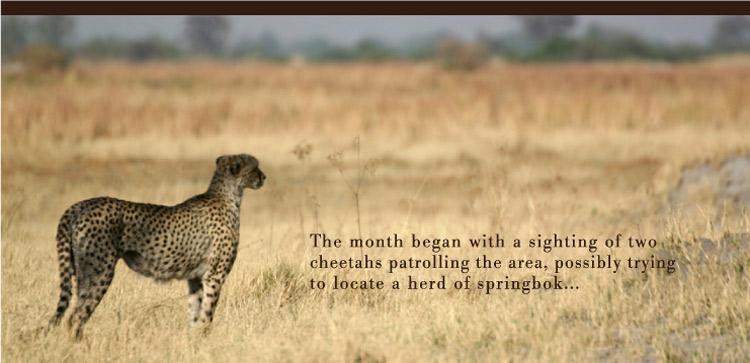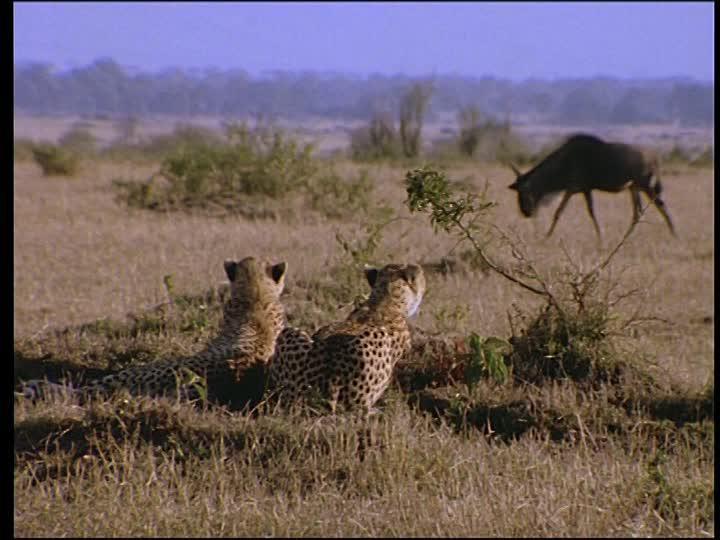The first image is the image on the left, the second image is the image on the right. Assess this claim about the two images: "Prey animals are visible in the background of the left image.". Correct or not? Answer yes or no. No. The first image is the image on the left, the second image is the image on the right. Given the left and right images, does the statement "Two cheetahs are running." hold true? Answer yes or no. No. 